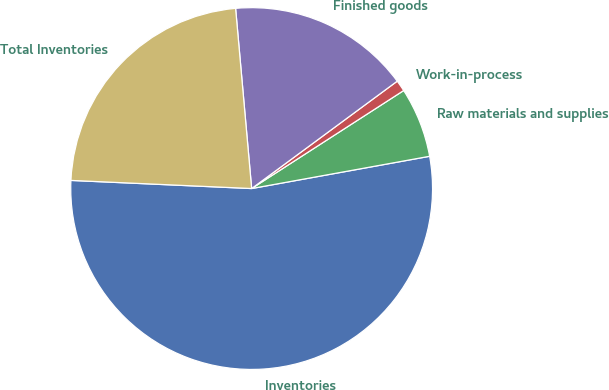Convert chart. <chart><loc_0><loc_0><loc_500><loc_500><pie_chart><fcel>Inventories<fcel>Raw materials and supplies<fcel>Work-in-process<fcel>Finished goods<fcel>Total Inventories<nl><fcel>53.57%<fcel>6.26%<fcel>1.0%<fcel>16.3%<fcel>22.87%<nl></chart> 